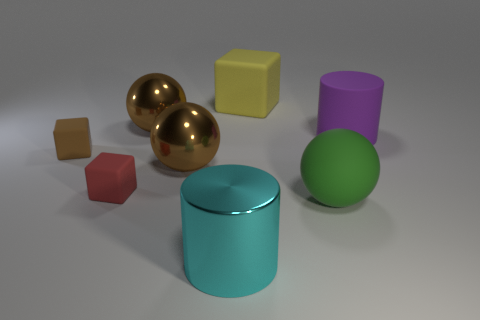There is a cylinder that is the same size as the cyan object; what is it made of?
Provide a succinct answer. Rubber. What number of things are either cubes that are right of the red thing or matte things to the left of the large green rubber object?
Provide a short and direct response. 3. There is a ball that is made of the same material as the small red block; what is its size?
Provide a short and direct response. Large. What number of metal things are either large gray cylinders or brown blocks?
Give a very brief answer. 0. What is the size of the purple object?
Give a very brief answer. Large. Does the cyan cylinder have the same size as the green matte thing?
Keep it short and to the point. Yes. There is a large sphere to the right of the large cyan cylinder; what is it made of?
Offer a very short reply. Rubber. What is the material of the big yellow object that is the same shape as the red object?
Ensure brevity in your answer.  Rubber. There is a large ball that is to the right of the yellow rubber block; are there any shiny things that are in front of it?
Provide a succinct answer. Yes. Is the shape of the big yellow object the same as the big cyan metal object?
Give a very brief answer. No. 